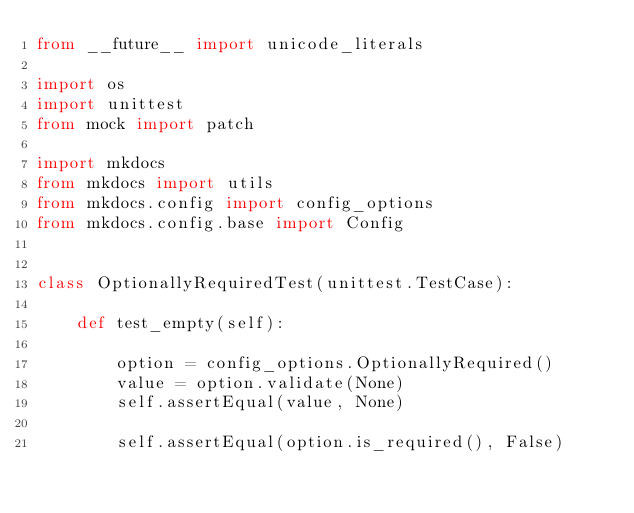<code> <loc_0><loc_0><loc_500><loc_500><_Python_>from __future__ import unicode_literals

import os
import unittest
from mock import patch

import mkdocs
from mkdocs import utils
from mkdocs.config import config_options
from mkdocs.config.base import Config


class OptionallyRequiredTest(unittest.TestCase):

    def test_empty(self):

        option = config_options.OptionallyRequired()
        value = option.validate(None)
        self.assertEqual(value, None)

        self.assertEqual(option.is_required(), False)
</code> 